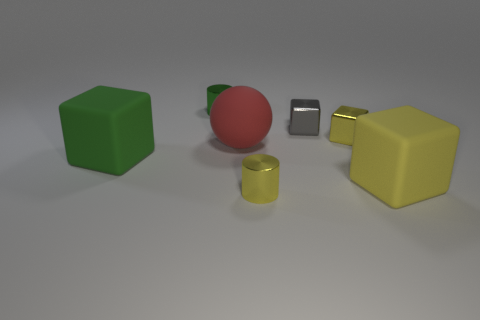Add 1 small metal blocks. How many objects exist? 8 Subtract all blue cylinders. How many yellow blocks are left? 2 Subtract all green cubes. How many cubes are left? 3 Subtract 0 red cylinders. How many objects are left? 7 Subtract all cylinders. How many objects are left? 5 Subtract all cyan blocks. Subtract all red balls. How many blocks are left? 4 Subtract all blue matte blocks. Subtract all green shiny things. How many objects are left? 6 Add 6 tiny gray metal blocks. How many tiny gray metal blocks are left? 7 Add 3 yellow cubes. How many yellow cubes exist? 5 